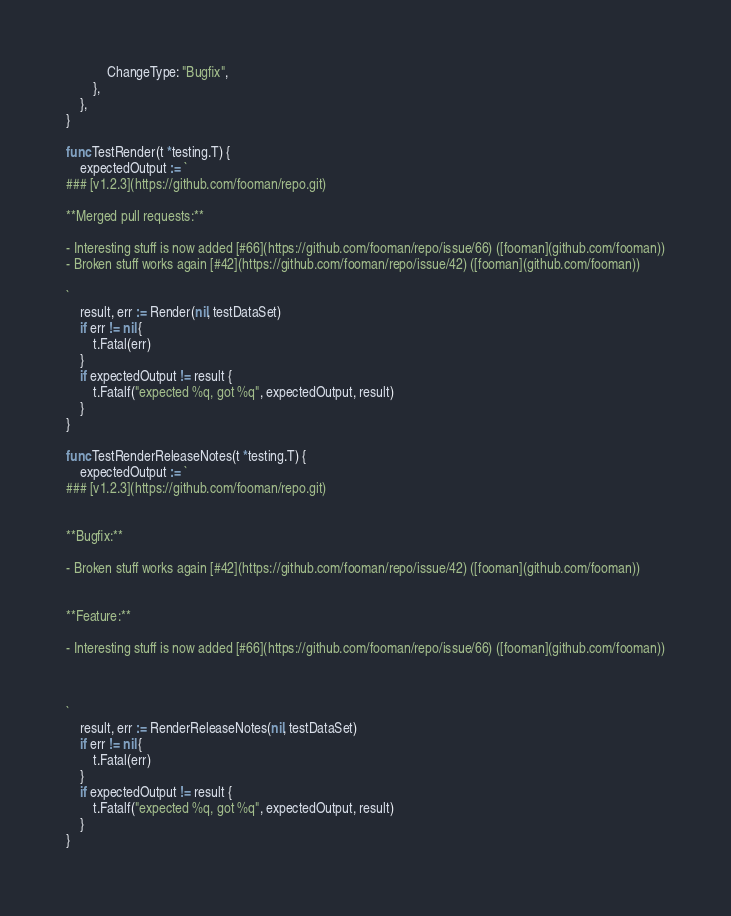Convert code to text. <code><loc_0><loc_0><loc_500><loc_500><_Go_>			ChangeType: "Bugfix",
		},
	},
}

func TestRender(t *testing.T) {
	expectedOutput := `
### [v1.2.3](https://github.com/fooman/repo.git)

**Merged pull requests:**

- Interesting stuff is now added [#66](https://github.com/fooman/repo/issue/66) ([fooman](github.com/fooman))
- Broken stuff works again [#42](https://github.com/fooman/repo/issue/42) ([fooman](github.com/fooman))

`
	result, err := Render(nil, testDataSet)
	if err != nil {
		t.Fatal(err)
	}
	if expectedOutput != result {
		t.Fatalf("expected %q, got %q", expectedOutput, result)
	}
}

func TestRenderReleaseNotes(t *testing.T) {
	expectedOutput := `
### [v1.2.3](https://github.com/fooman/repo.git)


**Bugfix:**

- Broken stuff works again [#42](https://github.com/fooman/repo/issue/42) ([fooman](github.com/fooman))


**Feature:**

- Interesting stuff is now added [#66](https://github.com/fooman/repo/issue/66) ([fooman](github.com/fooman))



`
	result, err := RenderReleaseNotes(nil, testDataSet)
	if err != nil {
		t.Fatal(err)
	}
	if expectedOutput != result {
		t.Fatalf("expected %q, got %q", expectedOutput, result)
	}
}
</code> 